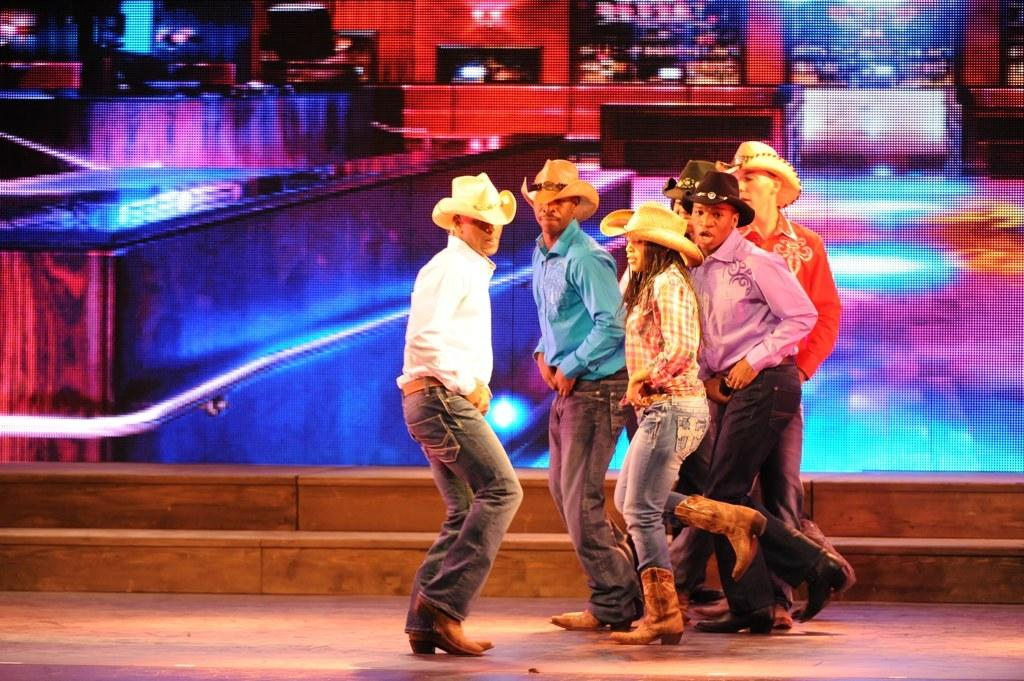What are the people in the image doing? The people in the image are dancing. What can be seen on the heads of the people in the image? The people are wearing hats on their heads. What is visible in the background of the image? There appears to be a screen in the background of the image. How many grapes are being attacked by the people in the image? There are no grapes present in the image, nor is there any indication of an attack. 